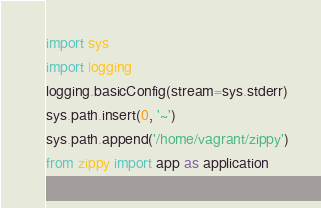Convert code to text. <code><loc_0><loc_0><loc_500><loc_500><_Python_>import sys
import logging
logging.basicConfig(stream=sys.stderr)
sys.path.insert(0, '~')
sys.path.append('/home/vagrant/zippy')
from zippy import app as application
</code> 